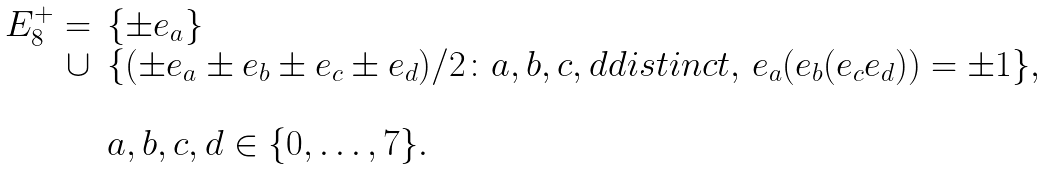<formula> <loc_0><loc_0><loc_500><loc_500>\begin{array} { r l } E _ { 8 } ^ { + } = & \{ \pm e _ { a } \} \\ \cup & \{ ( \pm e _ { a } \pm e _ { b } \pm e _ { c } \pm e _ { d } ) / 2 \colon a , b , c , d d i s t i n c t , \, e _ { a } ( e _ { b } ( e _ { c } e _ { d } ) ) = \pm 1 \} , \\ \\ & a , b , c , d \in \{ 0 , \dots , 7 \} . \\ \end{array}</formula> 